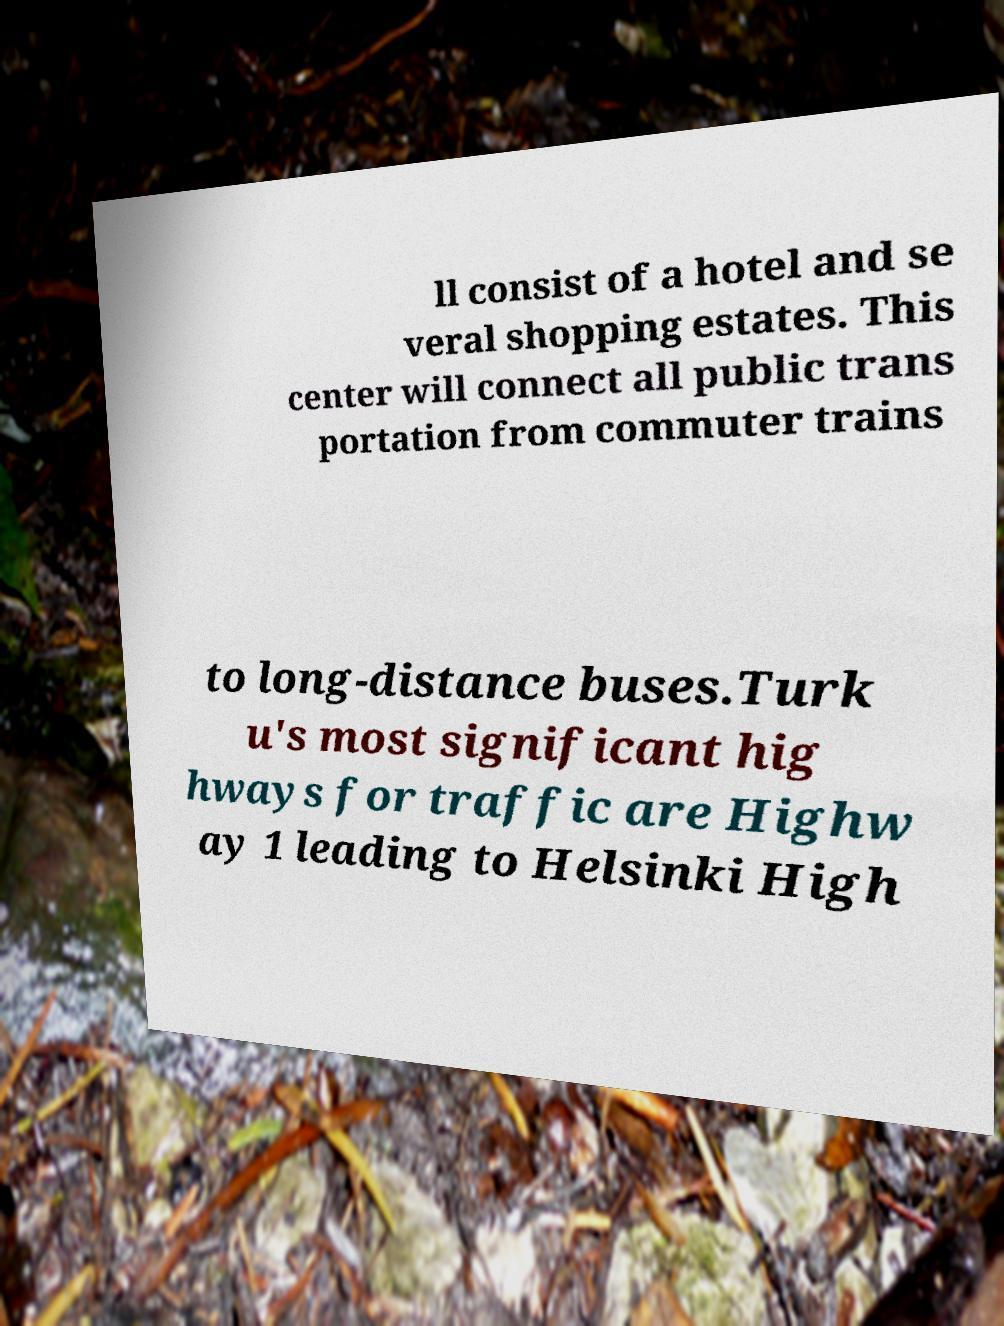Please identify and transcribe the text found in this image. ll consist of a hotel and se veral shopping estates. This center will connect all public trans portation from commuter trains to long-distance buses.Turk u's most significant hig hways for traffic are Highw ay 1 leading to Helsinki High 